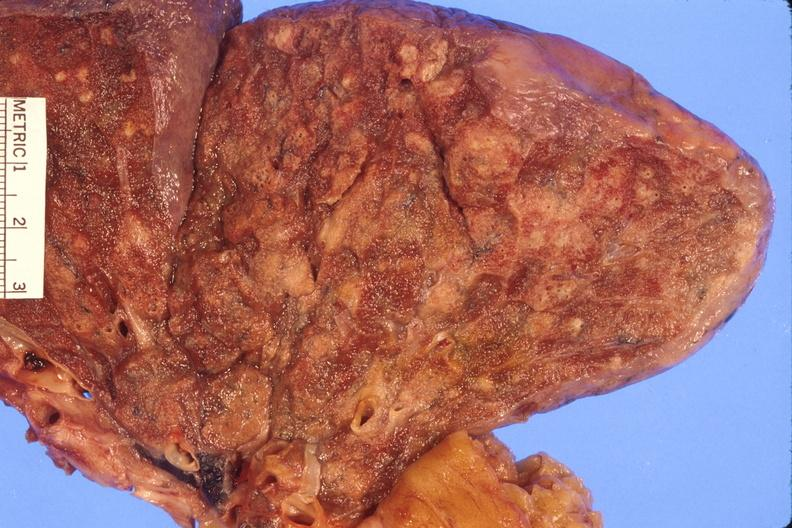s metastatic carcinoma lung present?
Answer the question using a single word or phrase. No 